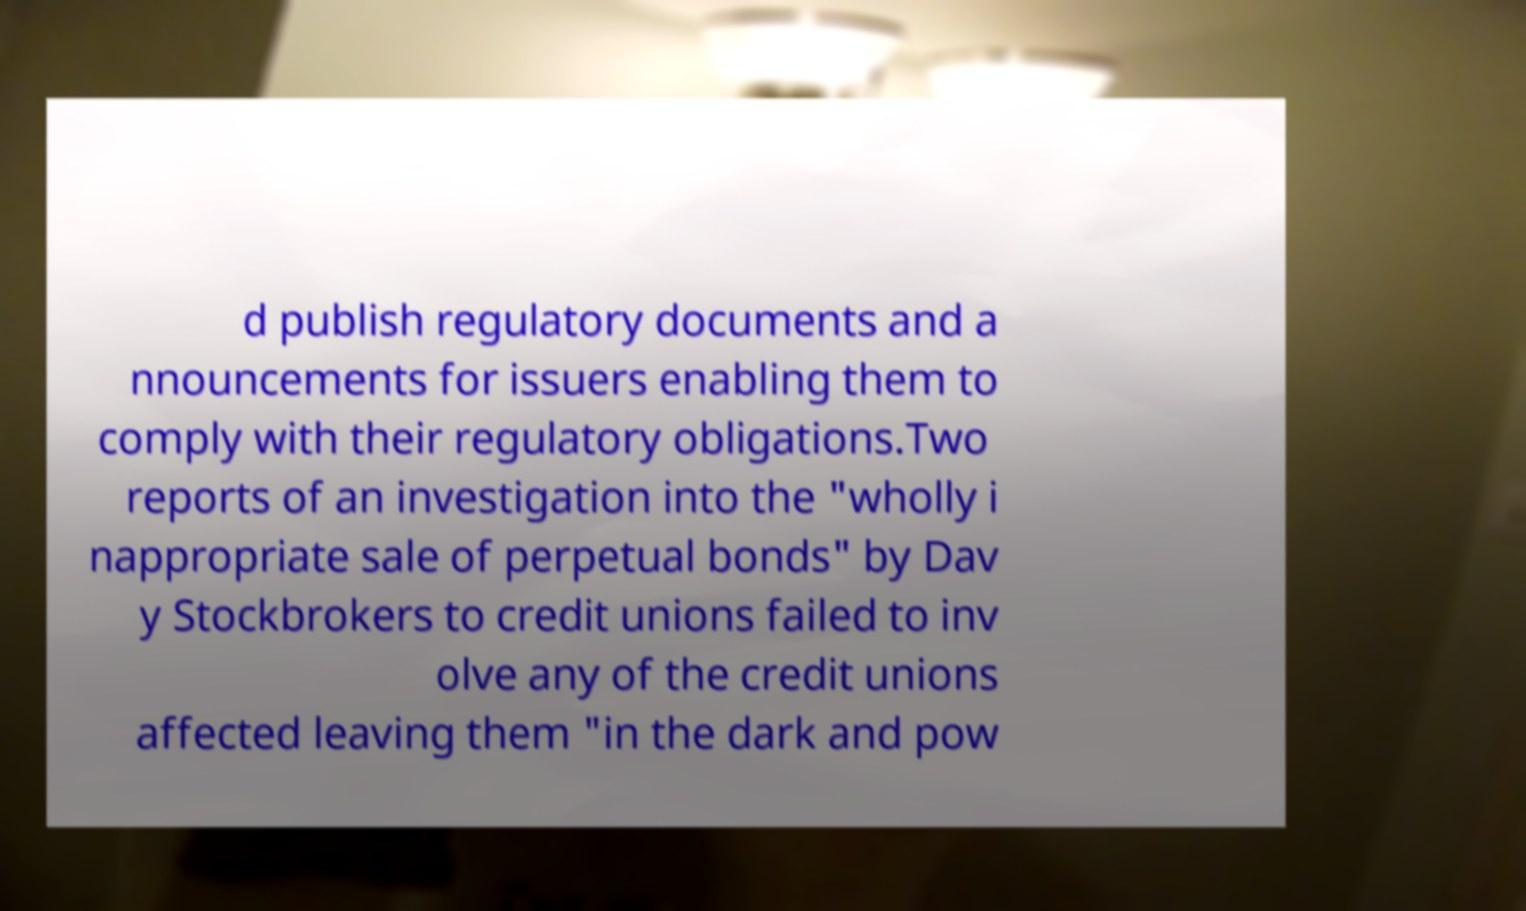Can you read and provide the text displayed in the image?This photo seems to have some interesting text. Can you extract and type it out for me? d publish regulatory documents and a nnouncements for issuers enabling them to comply with their regulatory obligations.Two reports of an investigation into the "wholly i nappropriate sale of perpetual bonds" by Dav y Stockbrokers to credit unions failed to inv olve any of the credit unions affected leaving them "in the dark and pow 